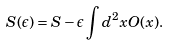Convert formula to latex. <formula><loc_0><loc_0><loc_500><loc_500>S ( \epsilon ) = S - \epsilon \int d ^ { 2 } x O ( x ) .</formula> 